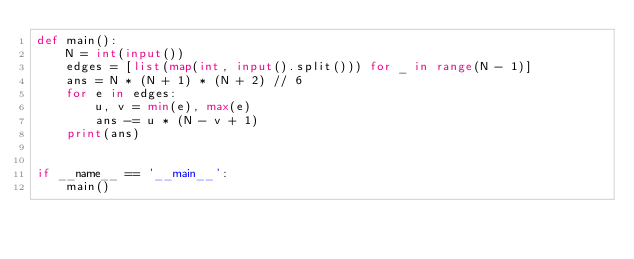Convert code to text. <code><loc_0><loc_0><loc_500><loc_500><_Python_>def main():
    N = int(input())
    edges = [list(map(int, input().split())) for _ in range(N - 1)]
    ans = N * (N + 1) * (N + 2) // 6
    for e in edges:
        u, v = min(e), max(e)
        ans -= u * (N - v + 1)
    print(ans)


if __name__ == '__main__':
    main()</code> 